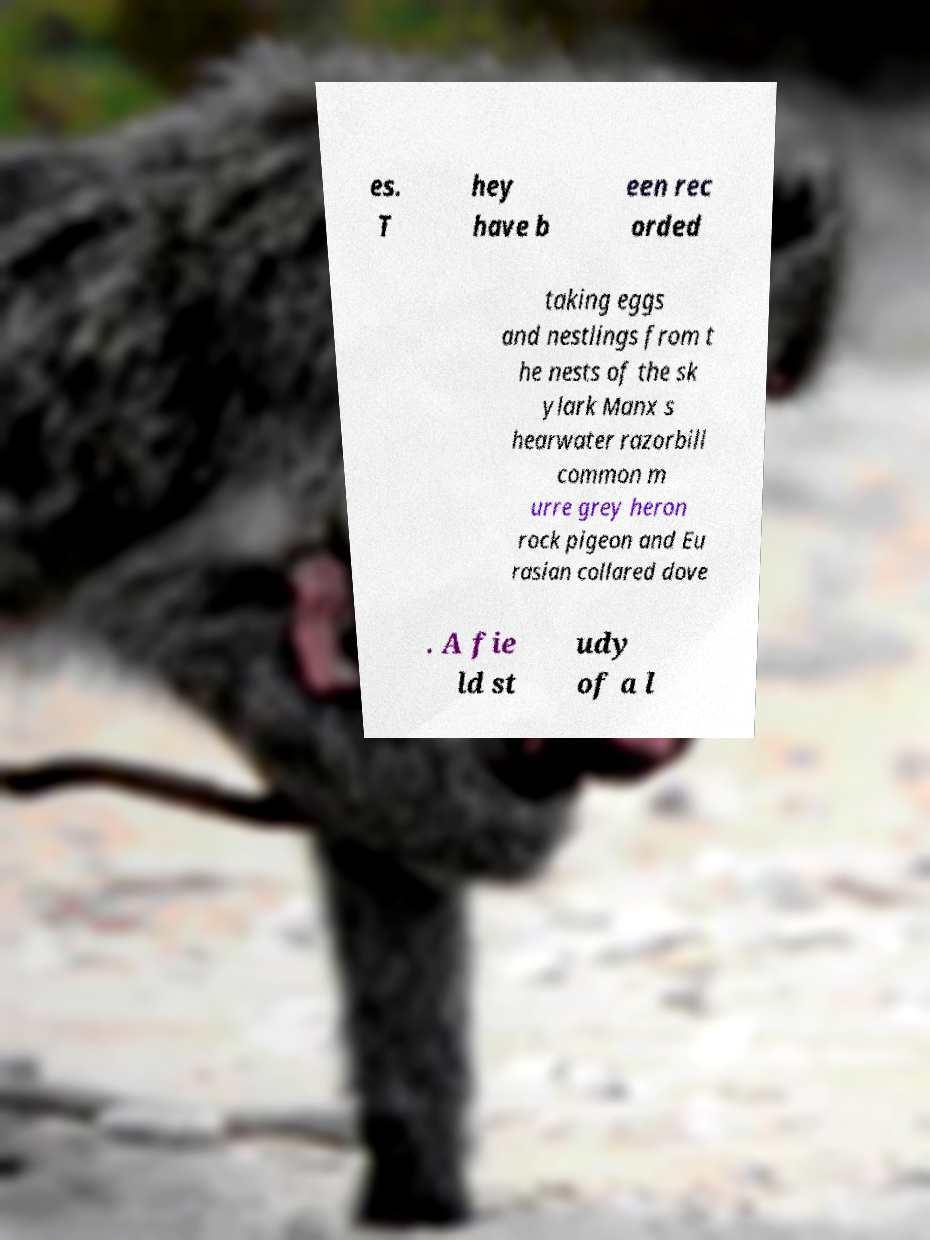For documentation purposes, I need the text within this image transcribed. Could you provide that? es. T hey have b een rec orded taking eggs and nestlings from t he nests of the sk ylark Manx s hearwater razorbill common m urre grey heron rock pigeon and Eu rasian collared dove . A fie ld st udy of a l 